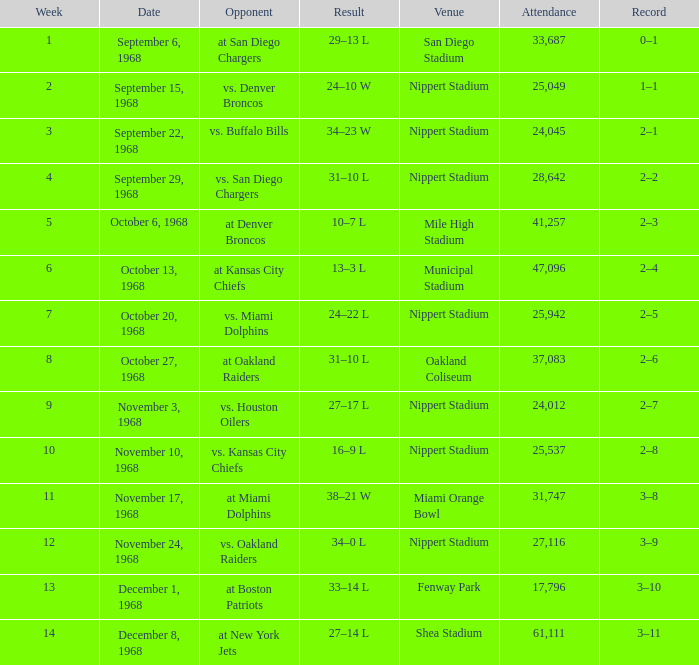When was the week 6 game held? October 13, 1968. Parse the full table. {'header': ['Week', 'Date', 'Opponent', 'Result', 'Venue', 'Attendance', 'Record'], 'rows': [['1', 'September 6, 1968', 'at San Diego Chargers', '29–13 L', 'San Diego Stadium', '33,687', '0–1'], ['2', 'September 15, 1968', 'vs. Denver Broncos', '24–10 W', 'Nippert Stadium', '25,049', '1–1'], ['3', 'September 22, 1968', 'vs. Buffalo Bills', '34–23 W', 'Nippert Stadium', '24,045', '2–1'], ['4', 'September 29, 1968', 'vs. San Diego Chargers', '31–10 L', 'Nippert Stadium', '28,642', '2–2'], ['5', 'October 6, 1968', 'at Denver Broncos', '10–7 L', 'Mile High Stadium', '41,257', '2–3'], ['6', 'October 13, 1968', 'at Kansas City Chiefs', '13–3 L', 'Municipal Stadium', '47,096', '2–4'], ['7', 'October 20, 1968', 'vs. Miami Dolphins', '24–22 L', 'Nippert Stadium', '25,942', '2–5'], ['8', 'October 27, 1968', 'at Oakland Raiders', '31–10 L', 'Oakland Coliseum', '37,083', '2–6'], ['9', 'November 3, 1968', 'vs. Houston Oilers', '27–17 L', 'Nippert Stadium', '24,012', '2–7'], ['10', 'November 10, 1968', 'vs. Kansas City Chiefs', '16–9 L', 'Nippert Stadium', '25,537', '2–8'], ['11', 'November 17, 1968', 'at Miami Dolphins', '38–21 W', 'Miami Orange Bowl', '31,747', '3–8'], ['12', 'November 24, 1968', 'vs. Oakland Raiders', '34–0 L', 'Nippert Stadium', '27,116', '3–9'], ['13', 'December 1, 1968', 'at Boston Patriots', '33–14 L', 'Fenway Park', '17,796', '3–10'], ['14', 'December 8, 1968', 'at New York Jets', '27–14 L', 'Shea Stadium', '61,111', '3–11']]} 